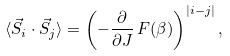Convert formula to latex. <formula><loc_0><loc_0><loc_500><loc_500>\langle \vec { S } _ { i } \cdot \vec { S } _ { j } \rangle = \left ( - \frac { \partial } { \partial J } \, F ( \beta ) \right ) ^ { | i - j | } ,</formula> 